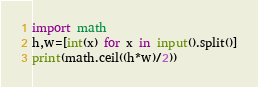Convert code to text. <code><loc_0><loc_0><loc_500><loc_500><_Python_>import math
h,w=[int(x) for x in input().split()]
print(math.ceil((h*w)/2))</code> 